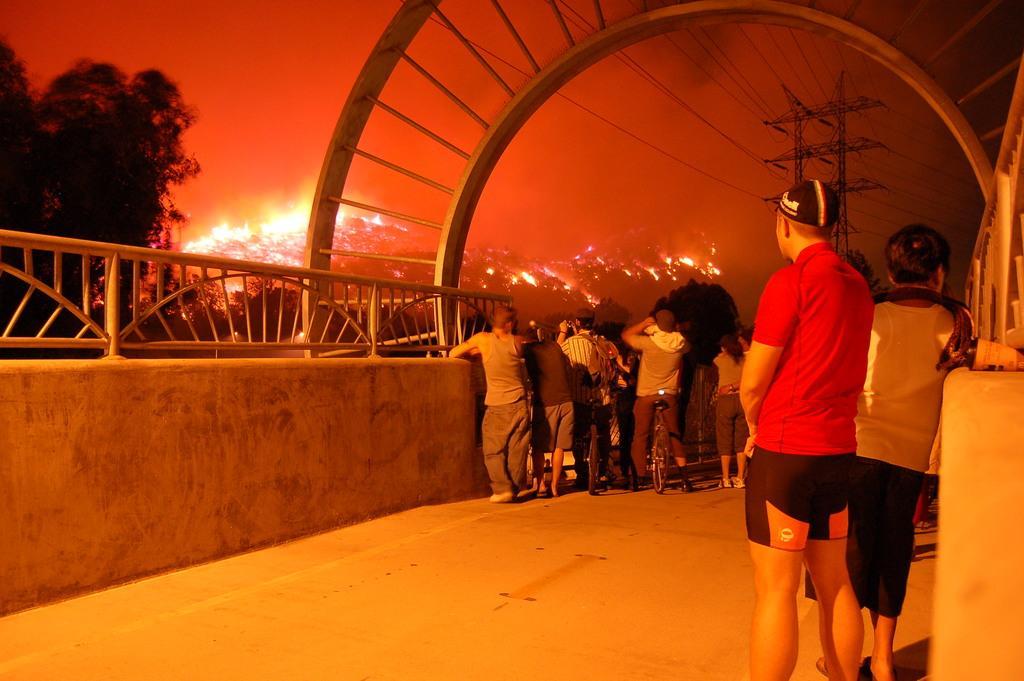How would you summarize this image in a sentence or two? In this image I can see a road , on the road I can see the wall and people standing in front of the wall and at the top I can see power line cables and towers and lights and trees , this picture is taken during night and I can see an arch visible at the top. 